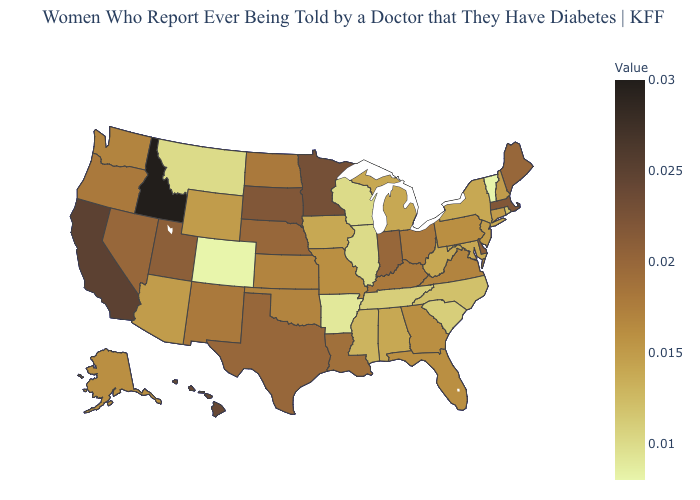Which states have the highest value in the USA?
Keep it brief. Idaho. Among the states that border North Dakota , which have the highest value?
Concise answer only. Minnesota. Does Kansas have a higher value than Nevada?
Short answer required. No. Which states have the lowest value in the West?
Be succinct. Colorado. Which states have the lowest value in the Northeast?
Keep it brief. Vermont. 